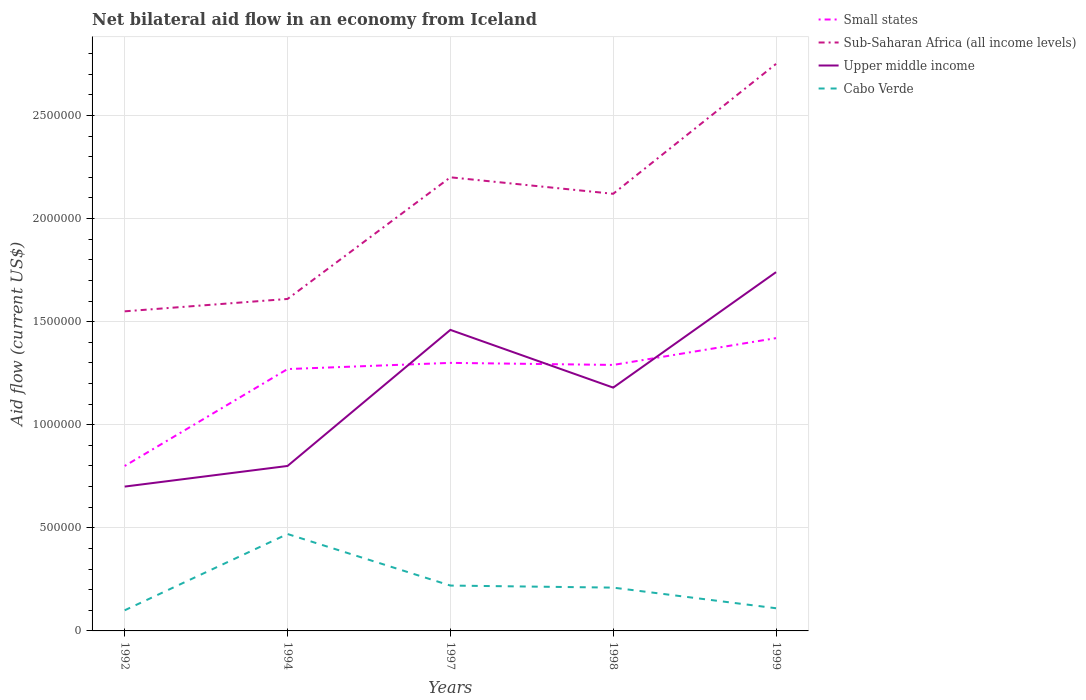How many different coloured lines are there?
Ensure brevity in your answer.  4. Does the line corresponding to Cabo Verde intersect with the line corresponding to Small states?
Keep it short and to the point. No. Is the number of lines equal to the number of legend labels?
Give a very brief answer. Yes. Across all years, what is the maximum net bilateral aid flow in Small states?
Your answer should be compact. 8.00e+05. In which year was the net bilateral aid flow in Sub-Saharan Africa (all income levels) maximum?
Give a very brief answer. 1992. What is the total net bilateral aid flow in Cabo Verde in the graph?
Make the answer very short. -1.10e+05. What is the difference between the highest and the second highest net bilateral aid flow in Sub-Saharan Africa (all income levels)?
Provide a short and direct response. 1.20e+06. What is the difference between the highest and the lowest net bilateral aid flow in Upper middle income?
Keep it short and to the point. 3. How many lines are there?
Offer a very short reply. 4. What is the difference between two consecutive major ticks on the Y-axis?
Provide a short and direct response. 5.00e+05. Does the graph contain any zero values?
Ensure brevity in your answer.  No. How many legend labels are there?
Your response must be concise. 4. How are the legend labels stacked?
Keep it short and to the point. Vertical. What is the title of the graph?
Keep it short and to the point. Net bilateral aid flow in an economy from Iceland. Does "Caribbean small states" appear as one of the legend labels in the graph?
Your answer should be compact. No. What is the label or title of the X-axis?
Make the answer very short. Years. What is the Aid flow (current US$) in Sub-Saharan Africa (all income levels) in 1992?
Your answer should be very brief. 1.55e+06. What is the Aid flow (current US$) in Upper middle income in 1992?
Your answer should be compact. 7.00e+05. What is the Aid flow (current US$) in Small states in 1994?
Keep it short and to the point. 1.27e+06. What is the Aid flow (current US$) in Sub-Saharan Africa (all income levels) in 1994?
Your answer should be compact. 1.61e+06. What is the Aid flow (current US$) in Upper middle income in 1994?
Provide a succinct answer. 8.00e+05. What is the Aid flow (current US$) of Small states in 1997?
Provide a short and direct response. 1.30e+06. What is the Aid flow (current US$) in Sub-Saharan Africa (all income levels) in 1997?
Offer a very short reply. 2.20e+06. What is the Aid flow (current US$) in Upper middle income in 1997?
Provide a succinct answer. 1.46e+06. What is the Aid flow (current US$) of Cabo Verde in 1997?
Offer a terse response. 2.20e+05. What is the Aid flow (current US$) of Small states in 1998?
Provide a succinct answer. 1.29e+06. What is the Aid flow (current US$) of Sub-Saharan Africa (all income levels) in 1998?
Provide a succinct answer. 2.12e+06. What is the Aid flow (current US$) in Upper middle income in 1998?
Make the answer very short. 1.18e+06. What is the Aid flow (current US$) in Cabo Verde in 1998?
Provide a succinct answer. 2.10e+05. What is the Aid flow (current US$) of Small states in 1999?
Your answer should be very brief. 1.42e+06. What is the Aid flow (current US$) in Sub-Saharan Africa (all income levels) in 1999?
Make the answer very short. 2.75e+06. What is the Aid flow (current US$) in Upper middle income in 1999?
Your answer should be compact. 1.74e+06. Across all years, what is the maximum Aid flow (current US$) of Small states?
Offer a very short reply. 1.42e+06. Across all years, what is the maximum Aid flow (current US$) of Sub-Saharan Africa (all income levels)?
Give a very brief answer. 2.75e+06. Across all years, what is the maximum Aid flow (current US$) of Upper middle income?
Your answer should be compact. 1.74e+06. Across all years, what is the maximum Aid flow (current US$) of Cabo Verde?
Provide a succinct answer. 4.70e+05. Across all years, what is the minimum Aid flow (current US$) of Sub-Saharan Africa (all income levels)?
Provide a short and direct response. 1.55e+06. Across all years, what is the minimum Aid flow (current US$) in Cabo Verde?
Provide a short and direct response. 1.00e+05. What is the total Aid flow (current US$) of Small states in the graph?
Provide a succinct answer. 6.08e+06. What is the total Aid flow (current US$) in Sub-Saharan Africa (all income levels) in the graph?
Provide a short and direct response. 1.02e+07. What is the total Aid flow (current US$) in Upper middle income in the graph?
Offer a very short reply. 5.88e+06. What is the total Aid flow (current US$) in Cabo Verde in the graph?
Your answer should be very brief. 1.11e+06. What is the difference between the Aid flow (current US$) of Small states in 1992 and that in 1994?
Offer a very short reply. -4.70e+05. What is the difference between the Aid flow (current US$) in Sub-Saharan Africa (all income levels) in 1992 and that in 1994?
Offer a terse response. -6.00e+04. What is the difference between the Aid flow (current US$) of Upper middle income in 1992 and that in 1994?
Ensure brevity in your answer.  -1.00e+05. What is the difference between the Aid flow (current US$) of Cabo Verde in 1992 and that in 1994?
Provide a succinct answer. -3.70e+05. What is the difference between the Aid flow (current US$) of Small states in 1992 and that in 1997?
Give a very brief answer. -5.00e+05. What is the difference between the Aid flow (current US$) in Sub-Saharan Africa (all income levels) in 1992 and that in 1997?
Offer a very short reply. -6.50e+05. What is the difference between the Aid flow (current US$) of Upper middle income in 1992 and that in 1997?
Make the answer very short. -7.60e+05. What is the difference between the Aid flow (current US$) of Small states in 1992 and that in 1998?
Provide a short and direct response. -4.90e+05. What is the difference between the Aid flow (current US$) in Sub-Saharan Africa (all income levels) in 1992 and that in 1998?
Provide a succinct answer. -5.70e+05. What is the difference between the Aid flow (current US$) in Upper middle income in 1992 and that in 1998?
Your answer should be very brief. -4.80e+05. What is the difference between the Aid flow (current US$) of Cabo Verde in 1992 and that in 1998?
Give a very brief answer. -1.10e+05. What is the difference between the Aid flow (current US$) in Small states in 1992 and that in 1999?
Your response must be concise. -6.20e+05. What is the difference between the Aid flow (current US$) in Sub-Saharan Africa (all income levels) in 1992 and that in 1999?
Offer a terse response. -1.20e+06. What is the difference between the Aid flow (current US$) of Upper middle income in 1992 and that in 1999?
Ensure brevity in your answer.  -1.04e+06. What is the difference between the Aid flow (current US$) in Sub-Saharan Africa (all income levels) in 1994 and that in 1997?
Your answer should be very brief. -5.90e+05. What is the difference between the Aid flow (current US$) of Upper middle income in 1994 and that in 1997?
Offer a very short reply. -6.60e+05. What is the difference between the Aid flow (current US$) of Small states in 1994 and that in 1998?
Provide a succinct answer. -2.00e+04. What is the difference between the Aid flow (current US$) of Sub-Saharan Africa (all income levels) in 1994 and that in 1998?
Keep it short and to the point. -5.10e+05. What is the difference between the Aid flow (current US$) of Upper middle income in 1994 and that in 1998?
Provide a short and direct response. -3.80e+05. What is the difference between the Aid flow (current US$) in Sub-Saharan Africa (all income levels) in 1994 and that in 1999?
Provide a short and direct response. -1.14e+06. What is the difference between the Aid flow (current US$) of Upper middle income in 1994 and that in 1999?
Your answer should be very brief. -9.40e+05. What is the difference between the Aid flow (current US$) in Small states in 1997 and that in 1999?
Provide a succinct answer. -1.20e+05. What is the difference between the Aid flow (current US$) in Sub-Saharan Africa (all income levels) in 1997 and that in 1999?
Your response must be concise. -5.50e+05. What is the difference between the Aid flow (current US$) of Upper middle income in 1997 and that in 1999?
Provide a succinct answer. -2.80e+05. What is the difference between the Aid flow (current US$) of Cabo Verde in 1997 and that in 1999?
Give a very brief answer. 1.10e+05. What is the difference between the Aid flow (current US$) in Small states in 1998 and that in 1999?
Give a very brief answer. -1.30e+05. What is the difference between the Aid flow (current US$) in Sub-Saharan Africa (all income levels) in 1998 and that in 1999?
Offer a very short reply. -6.30e+05. What is the difference between the Aid flow (current US$) in Upper middle income in 1998 and that in 1999?
Your answer should be very brief. -5.60e+05. What is the difference between the Aid flow (current US$) of Cabo Verde in 1998 and that in 1999?
Provide a short and direct response. 1.00e+05. What is the difference between the Aid flow (current US$) in Small states in 1992 and the Aid flow (current US$) in Sub-Saharan Africa (all income levels) in 1994?
Your response must be concise. -8.10e+05. What is the difference between the Aid flow (current US$) in Small states in 1992 and the Aid flow (current US$) in Upper middle income in 1994?
Make the answer very short. 0. What is the difference between the Aid flow (current US$) in Small states in 1992 and the Aid flow (current US$) in Cabo Verde in 1994?
Provide a succinct answer. 3.30e+05. What is the difference between the Aid flow (current US$) in Sub-Saharan Africa (all income levels) in 1992 and the Aid flow (current US$) in Upper middle income in 1994?
Provide a succinct answer. 7.50e+05. What is the difference between the Aid flow (current US$) of Sub-Saharan Africa (all income levels) in 1992 and the Aid flow (current US$) of Cabo Verde in 1994?
Offer a very short reply. 1.08e+06. What is the difference between the Aid flow (current US$) of Small states in 1992 and the Aid flow (current US$) of Sub-Saharan Africa (all income levels) in 1997?
Give a very brief answer. -1.40e+06. What is the difference between the Aid flow (current US$) of Small states in 1992 and the Aid flow (current US$) of Upper middle income in 1997?
Make the answer very short. -6.60e+05. What is the difference between the Aid flow (current US$) in Small states in 1992 and the Aid flow (current US$) in Cabo Verde in 1997?
Keep it short and to the point. 5.80e+05. What is the difference between the Aid flow (current US$) of Sub-Saharan Africa (all income levels) in 1992 and the Aid flow (current US$) of Cabo Verde in 1997?
Ensure brevity in your answer.  1.33e+06. What is the difference between the Aid flow (current US$) in Upper middle income in 1992 and the Aid flow (current US$) in Cabo Verde in 1997?
Give a very brief answer. 4.80e+05. What is the difference between the Aid flow (current US$) of Small states in 1992 and the Aid flow (current US$) of Sub-Saharan Africa (all income levels) in 1998?
Your answer should be very brief. -1.32e+06. What is the difference between the Aid flow (current US$) in Small states in 1992 and the Aid flow (current US$) in Upper middle income in 1998?
Keep it short and to the point. -3.80e+05. What is the difference between the Aid flow (current US$) in Small states in 1992 and the Aid flow (current US$) in Cabo Verde in 1998?
Provide a succinct answer. 5.90e+05. What is the difference between the Aid flow (current US$) of Sub-Saharan Africa (all income levels) in 1992 and the Aid flow (current US$) of Cabo Verde in 1998?
Your answer should be very brief. 1.34e+06. What is the difference between the Aid flow (current US$) in Upper middle income in 1992 and the Aid flow (current US$) in Cabo Verde in 1998?
Offer a very short reply. 4.90e+05. What is the difference between the Aid flow (current US$) in Small states in 1992 and the Aid flow (current US$) in Sub-Saharan Africa (all income levels) in 1999?
Offer a terse response. -1.95e+06. What is the difference between the Aid flow (current US$) of Small states in 1992 and the Aid flow (current US$) of Upper middle income in 1999?
Provide a short and direct response. -9.40e+05. What is the difference between the Aid flow (current US$) of Small states in 1992 and the Aid flow (current US$) of Cabo Verde in 1999?
Your answer should be compact. 6.90e+05. What is the difference between the Aid flow (current US$) in Sub-Saharan Africa (all income levels) in 1992 and the Aid flow (current US$) in Upper middle income in 1999?
Keep it short and to the point. -1.90e+05. What is the difference between the Aid flow (current US$) of Sub-Saharan Africa (all income levels) in 1992 and the Aid flow (current US$) of Cabo Verde in 1999?
Your answer should be compact. 1.44e+06. What is the difference between the Aid flow (current US$) in Upper middle income in 1992 and the Aid flow (current US$) in Cabo Verde in 1999?
Provide a succinct answer. 5.90e+05. What is the difference between the Aid flow (current US$) of Small states in 1994 and the Aid flow (current US$) of Sub-Saharan Africa (all income levels) in 1997?
Provide a short and direct response. -9.30e+05. What is the difference between the Aid flow (current US$) in Small states in 1994 and the Aid flow (current US$) in Cabo Verde in 1997?
Provide a succinct answer. 1.05e+06. What is the difference between the Aid flow (current US$) of Sub-Saharan Africa (all income levels) in 1994 and the Aid flow (current US$) of Upper middle income in 1997?
Provide a short and direct response. 1.50e+05. What is the difference between the Aid flow (current US$) of Sub-Saharan Africa (all income levels) in 1994 and the Aid flow (current US$) of Cabo Verde in 1997?
Provide a short and direct response. 1.39e+06. What is the difference between the Aid flow (current US$) in Upper middle income in 1994 and the Aid flow (current US$) in Cabo Verde in 1997?
Offer a very short reply. 5.80e+05. What is the difference between the Aid flow (current US$) in Small states in 1994 and the Aid flow (current US$) in Sub-Saharan Africa (all income levels) in 1998?
Give a very brief answer. -8.50e+05. What is the difference between the Aid flow (current US$) in Small states in 1994 and the Aid flow (current US$) in Cabo Verde in 1998?
Provide a succinct answer. 1.06e+06. What is the difference between the Aid flow (current US$) of Sub-Saharan Africa (all income levels) in 1994 and the Aid flow (current US$) of Upper middle income in 1998?
Your answer should be very brief. 4.30e+05. What is the difference between the Aid flow (current US$) of Sub-Saharan Africa (all income levels) in 1994 and the Aid flow (current US$) of Cabo Verde in 1998?
Your answer should be very brief. 1.40e+06. What is the difference between the Aid flow (current US$) in Upper middle income in 1994 and the Aid flow (current US$) in Cabo Verde in 1998?
Offer a very short reply. 5.90e+05. What is the difference between the Aid flow (current US$) in Small states in 1994 and the Aid flow (current US$) in Sub-Saharan Africa (all income levels) in 1999?
Keep it short and to the point. -1.48e+06. What is the difference between the Aid flow (current US$) of Small states in 1994 and the Aid flow (current US$) of Upper middle income in 1999?
Your answer should be very brief. -4.70e+05. What is the difference between the Aid flow (current US$) in Small states in 1994 and the Aid flow (current US$) in Cabo Verde in 1999?
Your response must be concise. 1.16e+06. What is the difference between the Aid flow (current US$) in Sub-Saharan Africa (all income levels) in 1994 and the Aid flow (current US$) in Upper middle income in 1999?
Your answer should be very brief. -1.30e+05. What is the difference between the Aid flow (current US$) of Sub-Saharan Africa (all income levels) in 1994 and the Aid flow (current US$) of Cabo Verde in 1999?
Make the answer very short. 1.50e+06. What is the difference between the Aid flow (current US$) of Upper middle income in 1994 and the Aid flow (current US$) of Cabo Verde in 1999?
Offer a very short reply. 6.90e+05. What is the difference between the Aid flow (current US$) of Small states in 1997 and the Aid flow (current US$) of Sub-Saharan Africa (all income levels) in 1998?
Provide a succinct answer. -8.20e+05. What is the difference between the Aid flow (current US$) in Small states in 1997 and the Aid flow (current US$) in Upper middle income in 1998?
Ensure brevity in your answer.  1.20e+05. What is the difference between the Aid flow (current US$) of Small states in 1997 and the Aid flow (current US$) of Cabo Verde in 1998?
Your answer should be compact. 1.09e+06. What is the difference between the Aid flow (current US$) of Sub-Saharan Africa (all income levels) in 1997 and the Aid flow (current US$) of Upper middle income in 1998?
Your response must be concise. 1.02e+06. What is the difference between the Aid flow (current US$) of Sub-Saharan Africa (all income levels) in 1997 and the Aid flow (current US$) of Cabo Verde in 1998?
Ensure brevity in your answer.  1.99e+06. What is the difference between the Aid flow (current US$) of Upper middle income in 1997 and the Aid flow (current US$) of Cabo Verde in 1998?
Your response must be concise. 1.25e+06. What is the difference between the Aid flow (current US$) in Small states in 1997 and the Aid flow (current US$) in Sub-Saharan Africa (all income levels) in 1999?
Provide a short and direct response. -1.45e+06. What is the difference between the Aid flow (current US$) in Small states in 1997 and the Aid flow (current US$) in Upper middle income in 1999?
Your answer should be very brief. -4.40e+05. What is the difference between the Aid flow (current US$) of Small states in 1997 and the Aid flow (current US$) of Cabo Verde in 1999?
Give a very brief answer. 1.19e+06. What is the difference between the Aid flow (current US$) in Sub-Saharan Africa (all income levels) in 1997 and the Aid flow (current US$) in Cabo Verde in 1999?
Your answer should be compact. 2.09e+06. What is the difference between the Aid flow (current US$) of Upper middle income in 1997 and the Aid flow (current US$) of Cabo Verde in 1999?
Provide a succinct answer. 1.35e+06. What is the difference between the Aid flow (current US$) of Small states in 1998 and the Aid flow (current US$) of Sub-Saharan Africa (all income levels) in 1999?
Offer a very short reply. -1.46e+06. What is the difference between the Aid flow (current US$) of Small states in 1998 and the Aid flow (current US$) of Upper middle income in 1999?
Offer a terse response. -4.50e+05. What is the difference between the Aid flow (current US$) of Small states in 1998 and the Aid flow (current US$) of Cabo Verde in 1999?
Give a very brief answer. 1.18e+06. What is the difference between the Aid flow (current US$) in Sub-Saharan Africa (all income levels) in 1998 and the Aid flow (current US$) in Upper middle income in 1999?
Offer a very short reply. 3.80e+05. What is the difference between the Aid flow (current US$) in Sub-Saharan Africa (all income levels) in 1998 and the Aid flow (current US$) in Cabo Verde in 1999?
Your answer should be compact. 2.01e+06. What is the difference between the Aid flow (current US$) of Upper middle income in 1998 and the Aid flow (current US$) of Cabo Verde in 1999?
Offer a terse response. 1.07e+06. What is the average Aid flow (current US$) in Small states per year?
Give a very brief answer. 1.22e+06. What is the average Aid flow (current US$) of Sub-Saharan Africa (all income levels) per year?
Your answer should be very brief. 2.05e+06. What is the average Aid flow (current US$) in Upper middle income per year?
Your answer should be very brief. 1.18e+06. What is the average Aid flow (current US$) in Cabo Verde per year?
Offer a terse response. 2.22e+05. In the year 1992, what is the difference between the Aid flow (current US$) of Small states and Aid flow (current US$) of Sub-Saharan Africa (all income levels)?
Offer a very short reply. -7.50e+05. In the year 1992, what is the difference between the Aid flow (current US$) of Sub-Saharan Africa (all income levels) and Aid flow (current US$) of Upper middle income?
Provide a succinct answer. 8.50e+05. In the year 1992, what is the difference between the Aid flow (current US$) of Sub-Saharan Africa (all income levels) and Aid flow (current US$) of Cabo Verde?
Give a very brief answer. 1.45e+06. In the year 1994, what is the difference between the Aid flow (current US$) of Small states and Aid flow (current US$) of Cabo Verde?
Offer a very short reply. 8.00e+05. In the year 1994, what is the difference between the Aid flow (current US$) of Sub-Saharan Africa (all income levels) and Aid flow (current US$) of Upper middle income?
Give a very brief answer. 8.10e+05. In the year 1994, what is the difference between the Aid flow (current US$) in Sub-Saharan Africa (all income levels) and Aid flow (current US$) in Cabo Verde?
Your answer should be very brief. 1.14e+06. In the year 1994, what is the difference between the Aid flow (current US$) in Upper middle income and Aid flow (current US$) in Cabo Verde?
Provide a succinct answer. 3.30e+05. In the year 1997, what is the difference between the Aid flow (current US$) of Small states and Aid flow (current US$) of Sub-Saharan Africa (all income levels)?
Give a very brief answer. -9.00e+05. In the year 1997, what is the difference between the Aid flow (current US$) of Small states and Aid flow (current US$) of Upper middle income?
Provide a succinct answer. -1.60e+05. In the year 1997, what is the difference between the Aid flow (current US$) in Small states and Aid flow (current US$) in Cabo Verde?
Provide a short and direct response. 1.08e+06. In the year 1997, what is the difference between the Aid flow (current US$) of Sub-Saharan Africa (all income levels) and Aid flow (current US$) of Upper middle income?
Keep it short and to the point. 7.40e+05. In the year 1997, what is the difference between the Aid flow (current US$) in Sub-Saharan Africa (all income levels) and Aid flow (current US$) in Cabo Verde?
Make the answer very short. 1.98e+06. In the year 1997, what is the difference between the Aid flow (current US$) of Upper middle income and Aid flow (current US$) of Cabo Verde?
Your answer should be very brief. 1.24e+06. In the year 1998, what is the difference between the Aid flow (current US$) of Small states and Aid flow (current US$) of Sub-Saharan Africa (all income levels)?
Make the answer very short. -8.30e+05. In the year 1998, what is the difference between the Aid flow (current US$) of Small states and Aid flow (current US$) of Upper middle income?
Provide a succinct answer. 1.10e+05. In the year 1998, what is the difference between the Aid flow (current US$) in Small states and Aid flow (current US$) in Cabo Verde?
Your response must be concise. 1.08e+06. In the year 1998, what is the difference between the Aid flow (current US$) of Sub-Saharan Africa (all income levels) and Aid flow (current US$) of Upper middle income?
Provide a succinct answer. 9.40e+05. In the year 1998, what is the difference between the Aid flow (current US$) of Sub-Saharan Africa (all income levels) and Aid flow (current US$) of Cabo Verde?
Provide a succinct answer. 1.91e+06. In the year 1998, what is the difference between the Aid flow (current US$) in Upper middle income and Aid flow (current US$) in Cabo Verde?
Offer a very short reply. 9.70e+05. In the year 1999, what is the difference between the Aid flow (current US$) in Small states and Aid flow (current US$) in Sub-Saharan Africa (all income levels)?
Your response must be concise. -1.33e+06. In the year 1999, what is the difference between the Aid flow (current US$) of Small states and Aid flow (current US$) of Upper middle income?
Give a very brief answer. -3.20e+05. In the year 1999, what is the difference between the Aid flow (current US$) in Small states and Aid flow (current US$) in Cabo Verde?
Ensure brevity in your answer.  1.31e+06. In the year 1999, what is the difference between the Aid flow (current US$) of Sub-Saharan Africa (all income levels) and Aid flow (current US$) of Upper middle income?
Your answer should be compact. 1.01e+06. In the year 1999, what is the difference between the Aid flow (current US$) in Sub-Saharan Africa (all income levels) and Aid flow (current US$) in Cabo Verde?
Provide a succinct answer. 2.64e+06. In the year 1999, what is the difference between the Aid flow (current US$) in Upper middle income and Aid flow (current US$) in Cabo Verde?
Keep it short and to the point. 1.63e+06. What is the ratio of the Aid flow (current US$) of Small states in 1992 to that in 1994?
Your answer should be very brief. 0.63. What is the ratio of the Aid flow (current US$) in Sub-Saharan Africa (all income levels) in 1992 to that in 1994?
Your answer should be very brief. 0.96. What is the ratio of the Aid flow (current US$) of Upper middle income in 1992 to that in 1994?
Your response must be concise. 0.88. What is the ratio of the Aid flow (current US$) of Cabo Verde in 1992 to that in 1994?
Your answer should be compact. 0.21. What is the ratio of the Aid flow (current US$) in Small states in 1992 to that in 1997?
Give a very brief answer. 0.62. What is the ratio of the Aid flow (current US$) of Sub-Saharan Africa (all income levels) in 1992 to that in 1997?
Your answer should be compact. 0.7. What is the ratio of the Aid flow (current US$) of Upper middle income in 1992 to that in 1997?
Provide a short and direct response. 0.48. What is the ratio of the Aid flow (current US$) of Cabo Verde in 1992 to that in 1997?
Your response must be concise. 0.45. What is the ratio of the Aid flow (current US$) in Small states in 1992 to that in 1998?
Give a very brief answer. 0.62. What is the ratio of the Aid flow (current US$) of Sub-Saharan Africa (all income levels) in 1992 to that in 1998?
Provide a succinct answer. 0.73. What is the ratio of the Aid flow (current US$) in Upper middle income in 1992 to that in 1998?
Offer a terse response. 0.59. What is the ratio of the Aid flow (current US$) of Cabo Verde in 1992 to that in 1998?
Ensure brevity in your answer.  0.48. What is the ratio of the Aid flow (current US$) of Small states in 1992 to that in 1999?
Your response must be concise. 0.56. What is the ratio of the Aid flow (current US$) of Sub-Saharan Africa (all income levels) in 1992 to that in 1999?
Provide a succinct answer. 0.56. What is the ratio of the Aid flow (current US$) of Upper middle income in 1992 to that in 1999?
Offer a very short reply. 0.4. What is the ratio of the Aid flow (current US$) of Small states in 1994 to that in 1997?
Offer a terse response. 0.98. What is the ratio of the Aid flow (current US$) in Sub-Saharan Africa (all income levels) in 1994 to that in 1997?
Give a very brief answer. 0.73. What is the ratio of the Aid flow (current US$) in Upper middle income in 1994 to that in 1997?
Keep it short and to the point. 0.55. What is the ratio of the Aid flow (current US$) of Cabo Verde in 1994 to that in 1997?
Keep it short and to the point. 2.14. What is the ratio of the Aid flow (current US$) in Small states in 1994 to that in 1998?
Make the answer very short. 0.98. What is the ratio of the Aid flow (current US$) in Sub-Saharan Africa (all income levels) in 1994 to that in 1998?
Keep it short and to the point. 0.76. What is the ratio of the Aid flow (current US$) of Upper middle income in 1994 to that in 1998?
Your response must be concise. 0.68. What is the ratio of the Aid flow (current US$) in Cabo Verde in 1994 to that in 1998?
Provide a short and direct response. 2.24. What is the ratio of the Aid flow (current US$) of Small states in 1994 to that in 1999?
Keep it short and to the point. 0.89. What is the ratio of the Aid flow (current US$) of Sub-Saharan Africa (all income levels) in 1994 to that in 1999?
Your answer should be very brief. 0.59. What is the ratio of the Aid flow (current US$) of Upper middle income in 1994 to that in 1999?
Your response must be concise. 0.46. What is the ratio of the Aid flow (current US$) in Cabo Verde in 1994 to that in 1999?
Provide a short and direct response. 4.27. What is the ratio of the Aid flow (current US$) of Small states in 1997 to that in 1998?
Your response must be concise. 1.01. What is the ratio of the Aid flow (current US$) in Sub-Saharan Africa (all income levels) in 1997 to that in 1998?
Ensure brevity in your answer.  1.04. What is the ratio of the Aid flow (current US$) in Upper middle income in 1997 to that in 1998?
Provide a succinct answer. 1.24. What is the ratio of the Aid flow (current US$) in Cabo Verde in 1997 to that in 1998?
Your answer should be compact. 1.05. What is the ratio of the Aid flow (current US$) of Small states in 1997 to that in 1999?
Offer a terse response. 0.92. What is the ratio of the Aid flow (current US$) in Sub-Saharan Africa (all income levels) in 1997 to that in 1999?
Make the answer very short. 0.8. What is the ratio of the Aid flow (current US$) in Upper middle income in 1997 to that in 1999?
Provide a short and direct response. 0.84. What is the ratio of the Aid flow (current US$) of Cabo Verde in 1997 to that in 1999?
Offer a very short reply. 2. What is the ratio of the Aid flow (current US$) of Small states in 1998 to that in 1999?
Offer a terse response. 0.91. What is the ratio of the Aid flow (current US$) of Sub-Saharan Africa (all income levels) in 1998 to that in 1999?
Ensure brevity in your answer.  0.77. What is the ratio of the Aid flow (current US$) in Upper middle income in 1998 to that in 1999?
Make the answer very short. 0.68. What is the ratio of the Aid flow (current US$) of Cabo Verde in 1998 to that in 1999?
Your answer should be compact. 1.91. What is the difference between the highest and the second highest Aid flow (current US$) of Small states?
Your answer should be compact. 1.20e+05. What is the difference between the highest and the second highest Aid flow (current US$) in Sub-Saharan Africa (all income levels)?
Offer a terse response. 5.50e+05. What is the difference between the highest and the second highest Aid flow (current US$) of Cabo Verde?
Your answer should be very brief. 2.50e+05. What is the difference between the highest and the lowest Aid flow (current US$) in Small states?
Your answer should be compact. 6.20e+05. What is the difference between the highest and the lowest Aid flow (current US$) of Sub-Saharan Africa (all income levels)?
Offer a very short reply. 1.20e+06. What is the difference between the highest and the lowest Aid flow (current US$) in Upper middle income?
Provide a succinct answer. 1.04e+06. 